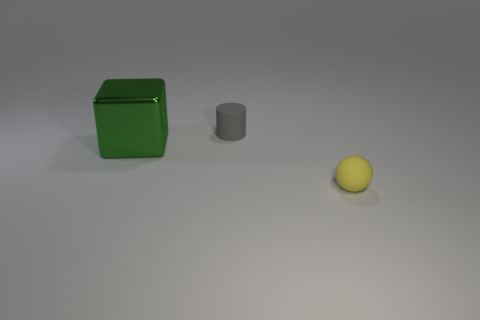Add 3 tiny cylinders. How many objects exist? 6 Subtract 0 gray cubes. How many objects are left? 3 Subtract all balls. How many objects are left? 2 Subtract 1 balls. How many balls are left? 0 Subtract all cyan cubes. Subtract all blue balls. How many cubes are left? 1 Subtract all yellow cylinders. How many cyan balls are left? 0 Subtract all gray matte objects. Subtract all green metallic objects. How many objects are left? 1 Add 3 tiny rubber objects. How many tiny rubber objects are left? 5 Add 2 tiny matte balls. How many tiny matte balls exist? 3 